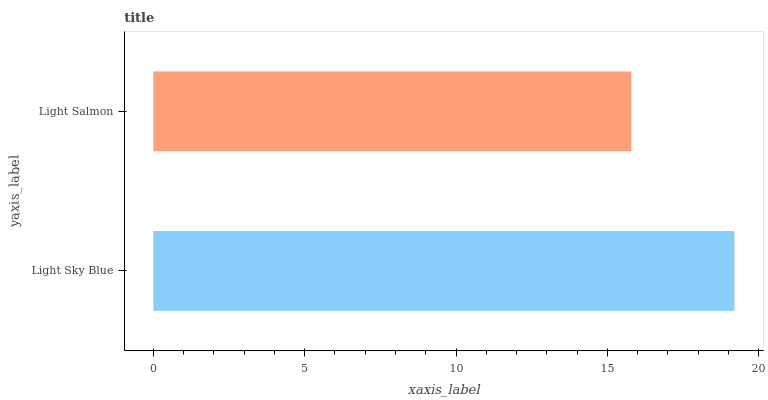Is Light Salmon the minimum?
Answer yes or no. Yes. Is Light Sky Blue the maximum?
Answer yes or no. Yes. Is Light Salmon the maximum?
Answer yes or no. No. Is Light Sky Blue greater than Light Salmon?
Answer yes or no. Yes. Is Light Salmon less than Light Sky Blue?
Answer yes or no. Yes. Is Light Salmon greater than Light Sky Blue?
Answer yes or no. No. Is Light Sky Blue less than Light Salmon?
Answer yes or no. No. Is Light Sky Blue the high median?
Answer yes or no. Yes. Is Light Salmon the low median?
Answer yes or no. Yes. Is Light Salmon the high median?
Answer yes or no. No. Is Light Sky Blue the low median?
Answer yes or no. No. 